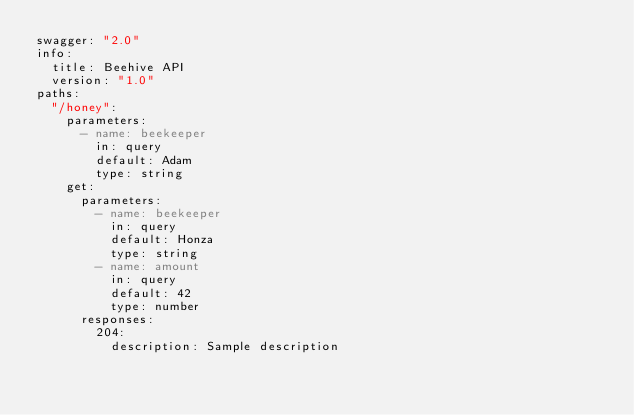<code> <loc_0><loc_0><loc_500><loc_500><_YAML_>swagger: "2.0"
info:
  title: Beehive API
  version: "1.0"
paths:
  "/honey":
    parameters:
      - name: beekeeper
        in: query
        default: Adam
        type: string
    get:
      parameters:
        - name: beekeeper
          in: query
          default: Honza
          type: string
        - name: amount
          in: query
          default: 42
          type: number
      responses:
        204:
          description: Sample description
</code> 